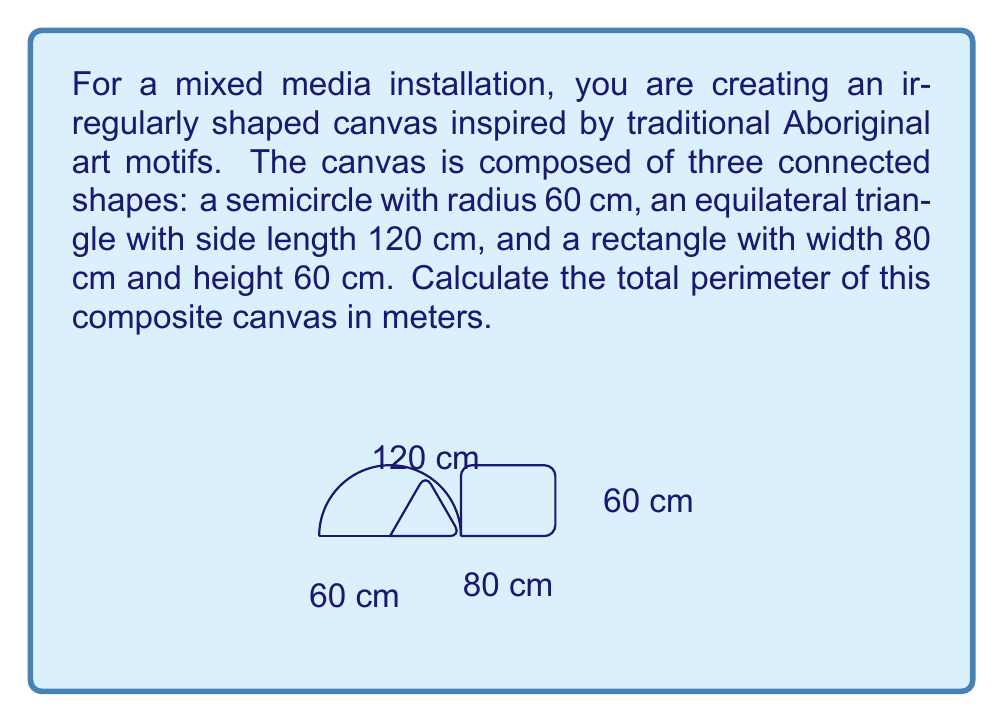Could you help me with this problem? Let's calculate the perimeter of each shape separately and then sum them up:

1. Semicircle:
   Perimeter of semicircle = $\pi r + 2r$
   $$ \text{Semicircle perimeter} = \pi \cdot 60 + 2 \cdot 60 = 60\pi + 120 \text{ cm} $$

2. Equilateral triangle:
   Perimeter of equilateral triangle = $3s$, where $s$ is the side length
   $$ \text{Triangle perimeter} = 3 \cdot 120 = 360 \text{ cm} $$

3. Rectangle:
   Perimeter of rectangle = $2(w + h)$, where $w$ is width and $h$ is height
   $$ \text{Rectangle perimeter} = 2(80 + 60) = 2 \cdot 140 = 280 \text{ cm} $$

Now, we need to subtract the lengths that are shared between shapes:
- The base of the semicircle (120 cm) is shared with the triangle and rectangle
- One side of the triangle (120 cm) is shared with the rectangle

Total shared length = $120 + 120 = 240 \text{ cm}$

Total perimeter = Semicircle + Triangle + Rectangle - Shared lengths
$$ \text{Total perimeter} = (60\pi + 120) + 360 + 280 - 240 $$
$$ = 60\pi + 520 \text{ cm} $$

Converting to meters:
$$ \text{Total perimeter in meters} = \frac{60\pi + 520}{100} = 0.6\pi + 5.2 \text{ m} $$
Answer: $0.6\pi + 5.2 \text{ m}$ 